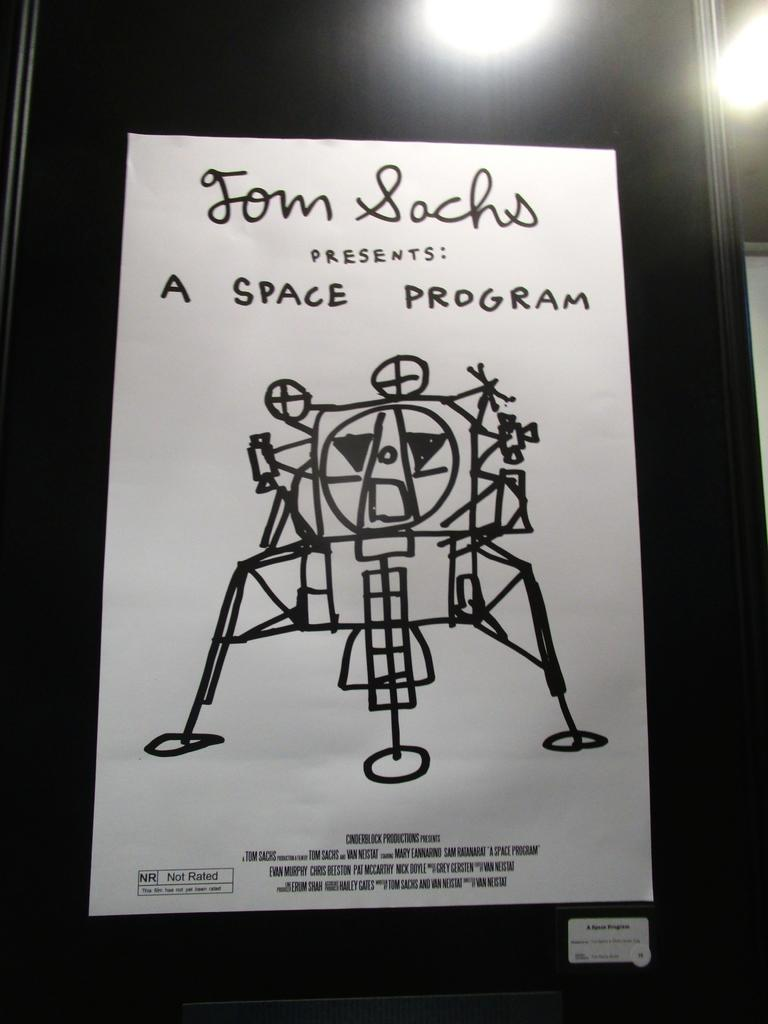<image>
Describe the image concisely. A piece of paper with the word space program written on it 